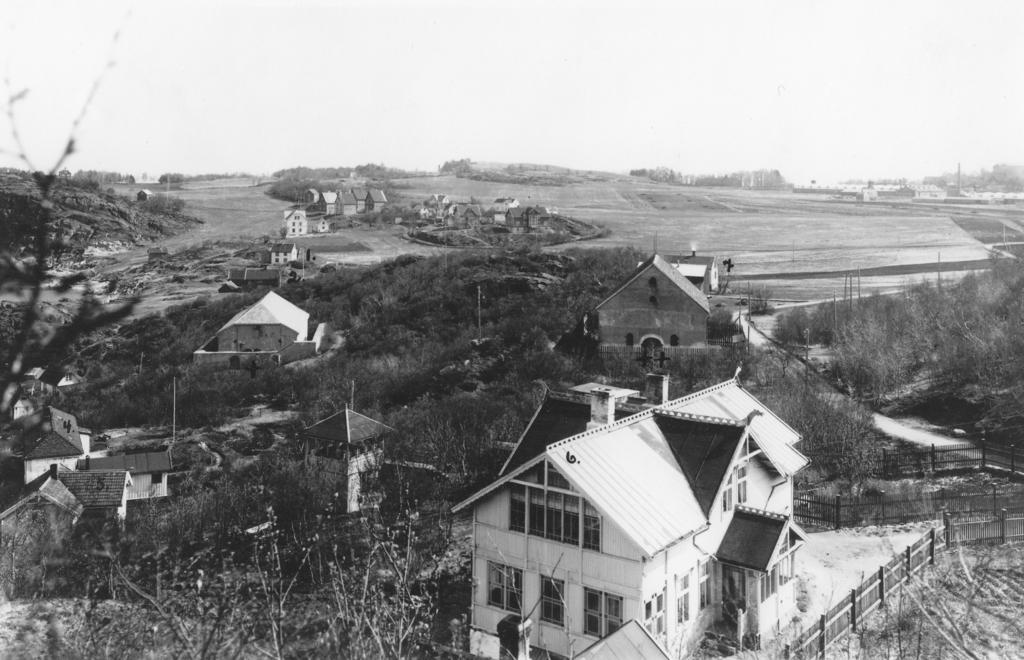In one or two sentences, can you explain what this image depicts? This is a black and white image. In this image we can see buildings, trees, plants, sand, fencing, road, grass and sky. 